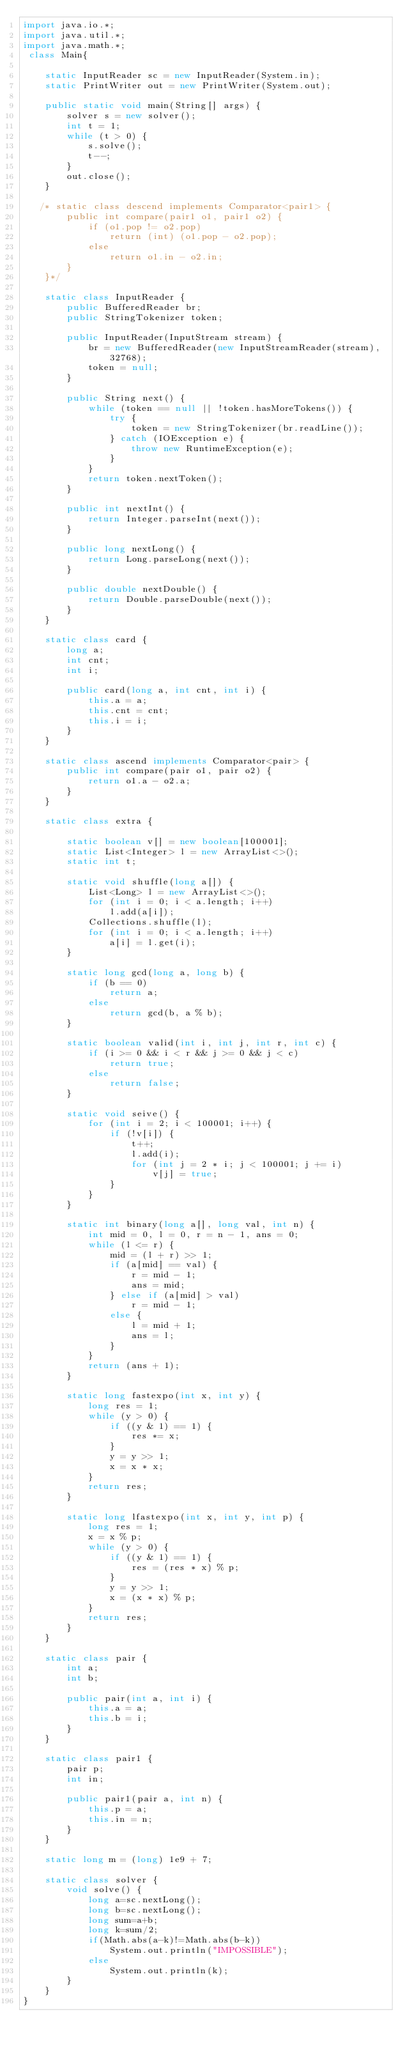<code> <loc_0><loc_0><loc_500><loc_500><_Java_>import java.io.*;
import java.util.*;
import java.math.*;
 class Main{

    static InputReader sc = new InputReader(System.in);
    static PrintWriter out = new PrintWriter(System.out);

    public static void main(String[] args) {
        solver s = new solver();
        int t = 1;
        while (t > 0) {
            s.solve();
            t--;
        }
        out.close();
    }

   /* static class descend implements Comparator<pair1> {
        public int compare(pair1 o1, pair1 o2) {
            if (o1.pop != o2.pop)
                return (int) (o1.pop - o2.pop);
            else
                return o1.in - o2.in;
        }
    }*/

    static class InputReader {
        public BufferedReader br;
        public StringTokenizer token;

        public InputReader(InputStream stream) {
            br = new BufferedReader(new InputStreamReader(stream), 32768);
            token = null;
        }

        public String next() {
            while (token == null || !token.hasMoreTokens()) {
                try {
                    token = new StringTokenizer(br.readLine());
                } catch (IOException e) {
                    throw new RuntimeException(e);
                }
            }
            return token.nextToken();
        }

        public int nextInt() {
            return Integer.parseInt(next());
        }

        public long nextLong() {
            return Long.parseLong(next());
        }

        public double nextDouble() {
            return Double.parseDouble(next());
        }
    }

    static class card {
        long a;
        int cnt;
        int i;

        public card(long a, int cnt, int i) {
            this.a = a;
            this.cnt = cnt;
            this.i = i;
        }
    }

    static class ascend implements Comparator<pair> {
        public int compare(pair o1, pair o2) {
            return o1.a - o2.a;
        }
    }

    static class extra {

        static boolean v[] = new boolean[100001];
        static List<Integer> l = new ArrayList<>();
        static int t;

        static void shuffle(long a[]) {
            List<Long> l = new ArrayList<>();
            for (int i = 0; i < a.length; i++)
                l.add(a[i]);
            Collections.shuffle(l);
            for (int i = 0; i < a.length; i++)
                a[i] = l.get(i);
        }

        static long gcd(long a, long b) {
            if (b == 0)
                return a;
            else
                return gcd(b, a % b);
        }

        static boolean valid(int i, int j, int r, int c) {
            if (i >= 0 && i < r && j >= 0 && j < c)
                return true;
            else
                return false;
        }

        static void seive() {
            for (int i = 2; i < 100001; i++) {
                if (!v[i]) {
                    t++;
                    l.add(i);
                    for (int j = 2 * i; j < 100001; j += i)
                        v[j] = true;
                }
            }
        }

        static int binary(long a[], long val, int n) {
            int mid = 0, l = 0, r = n - 1, ans = 0;
            while (l <= r) {
                mid = (l + r) >> 1;
                if (a[mid] == val) {
                    r = mid - 1;
                    ans = mid;
                } else if (a[mid] > val)
                    r = mid - 1;
                else {
                    l = mid + 1;
                    ans = l;
                }
            }
            return (ans + 1);
        }

        static long fastexpo(int x, int y) {
            long res = 1;
            while (y > 0) {
                if ((y & 1) == 1) {
                    res *= x;
                }
                y = y >> 1;
                x = x * x;
            }
            return res;
        }

        static long lfastexpo(int x, int y, int p) {
            long res = 1;
            x = x % p;
            while (y > 0) {
                if ((y & 1) == 1) {
                    res = (res * x) % p;
                }
                y = y >> 1;
                x = (x * x) % p;
            }
            return res;
        }
    }

    static class pair {
        int a;
        int b;

        public pair(int a, int i) {
            this.a = a;
            this.b = i;
        }
    }

    static class pair1 {
        pair p;
        int in;

        public pair1(pair a, int n) {
            this.p = a;
            this.in = n;
        }
    }

    static long m = (long) 1e9 + 7;

    static class solver {
        void solve() {
            long a=sc.nextLong();
            long b=sc.nextLong();
            long sum=a+b;
            long k=sum/2;
            if(Math.abs(a-k)!=Math.abs(b-k))
                System.out.println("IMPOSSIBLE");
            else
                System.out.println(k);
        }
    }
}</code> 